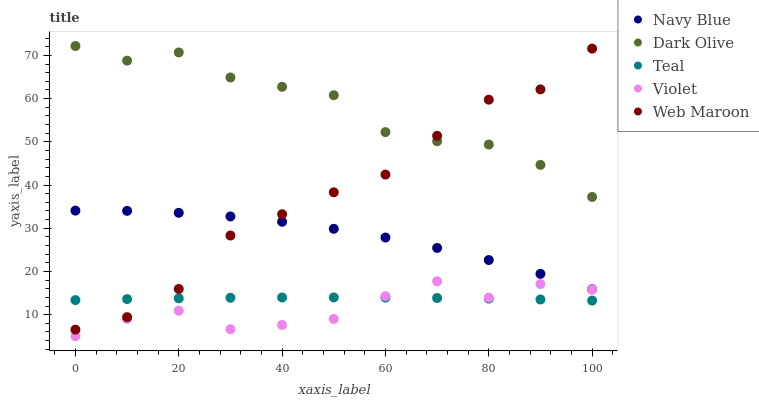Does Violet have the minimum area under the curve?
Answer yes or no. Yes. Does Dark Olive have the maximum area under the curve?
Answer yes or no. Yes. Does Web Maroon have the minimum area under the curve?
Answer yes or no. No. Does Web Maroon have the maximum area under the curve?
Answer yes or no. No. Is Teal the smoothest?
Answer yes or no. Yes. Is Violet the roughest?
Answer yes or no. Yes. Is Dark Olive the smoothest?
Answer yes or no. No. Is Dark Olive the roughest?
Answer yes or no. No. Does Violet have the lowest value?
Answer yes or no. Yes. Does Web Maroon have the lowest value?
Answer yes or no. No. Does Dark Olive have the highest value?
Answer yes or no. Yes. Does Web Maroon have the highest value?
Answer yes or no. No. Is Navy Blue less than Dark Olive?
Answer yes or no. Yes. Is Dark Olive greater than Teal?
Answer yes or no. Yes. Does Dark Olive intersect Web Maroon?
Answer yes or no. Yes. Is Dark Olive less than Web Maroon?
Answer yes or no. No. Is Dark Olive greater than Web Maroon?
Answer yes or no. No. Does Navy Blue intersect Dark Olive?
Answer yes or no. No. 